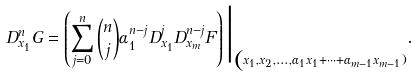Convert formula to latex. <formula><loc_0><loc_0><loc_500><loc_500>D ^ { n } _ { x _ { 1 } } G = \left ( \sum _ { j = 0 } ^ { n } { n \choose j } \alpha _ { 1 } ^ { n - j } D _ { x _ { 1 } } ^ { j } D _ { x _ { m } } ^ { n - j } F \right ) \Big | _ { \substack ( x _ { 1 } , x _ { 2 } , \dots , \alpha _ { 1 } x _ { 1 } + \cdots + \alpha _ { m - 1 } x _ { m - 1 } ) } .</formula> 